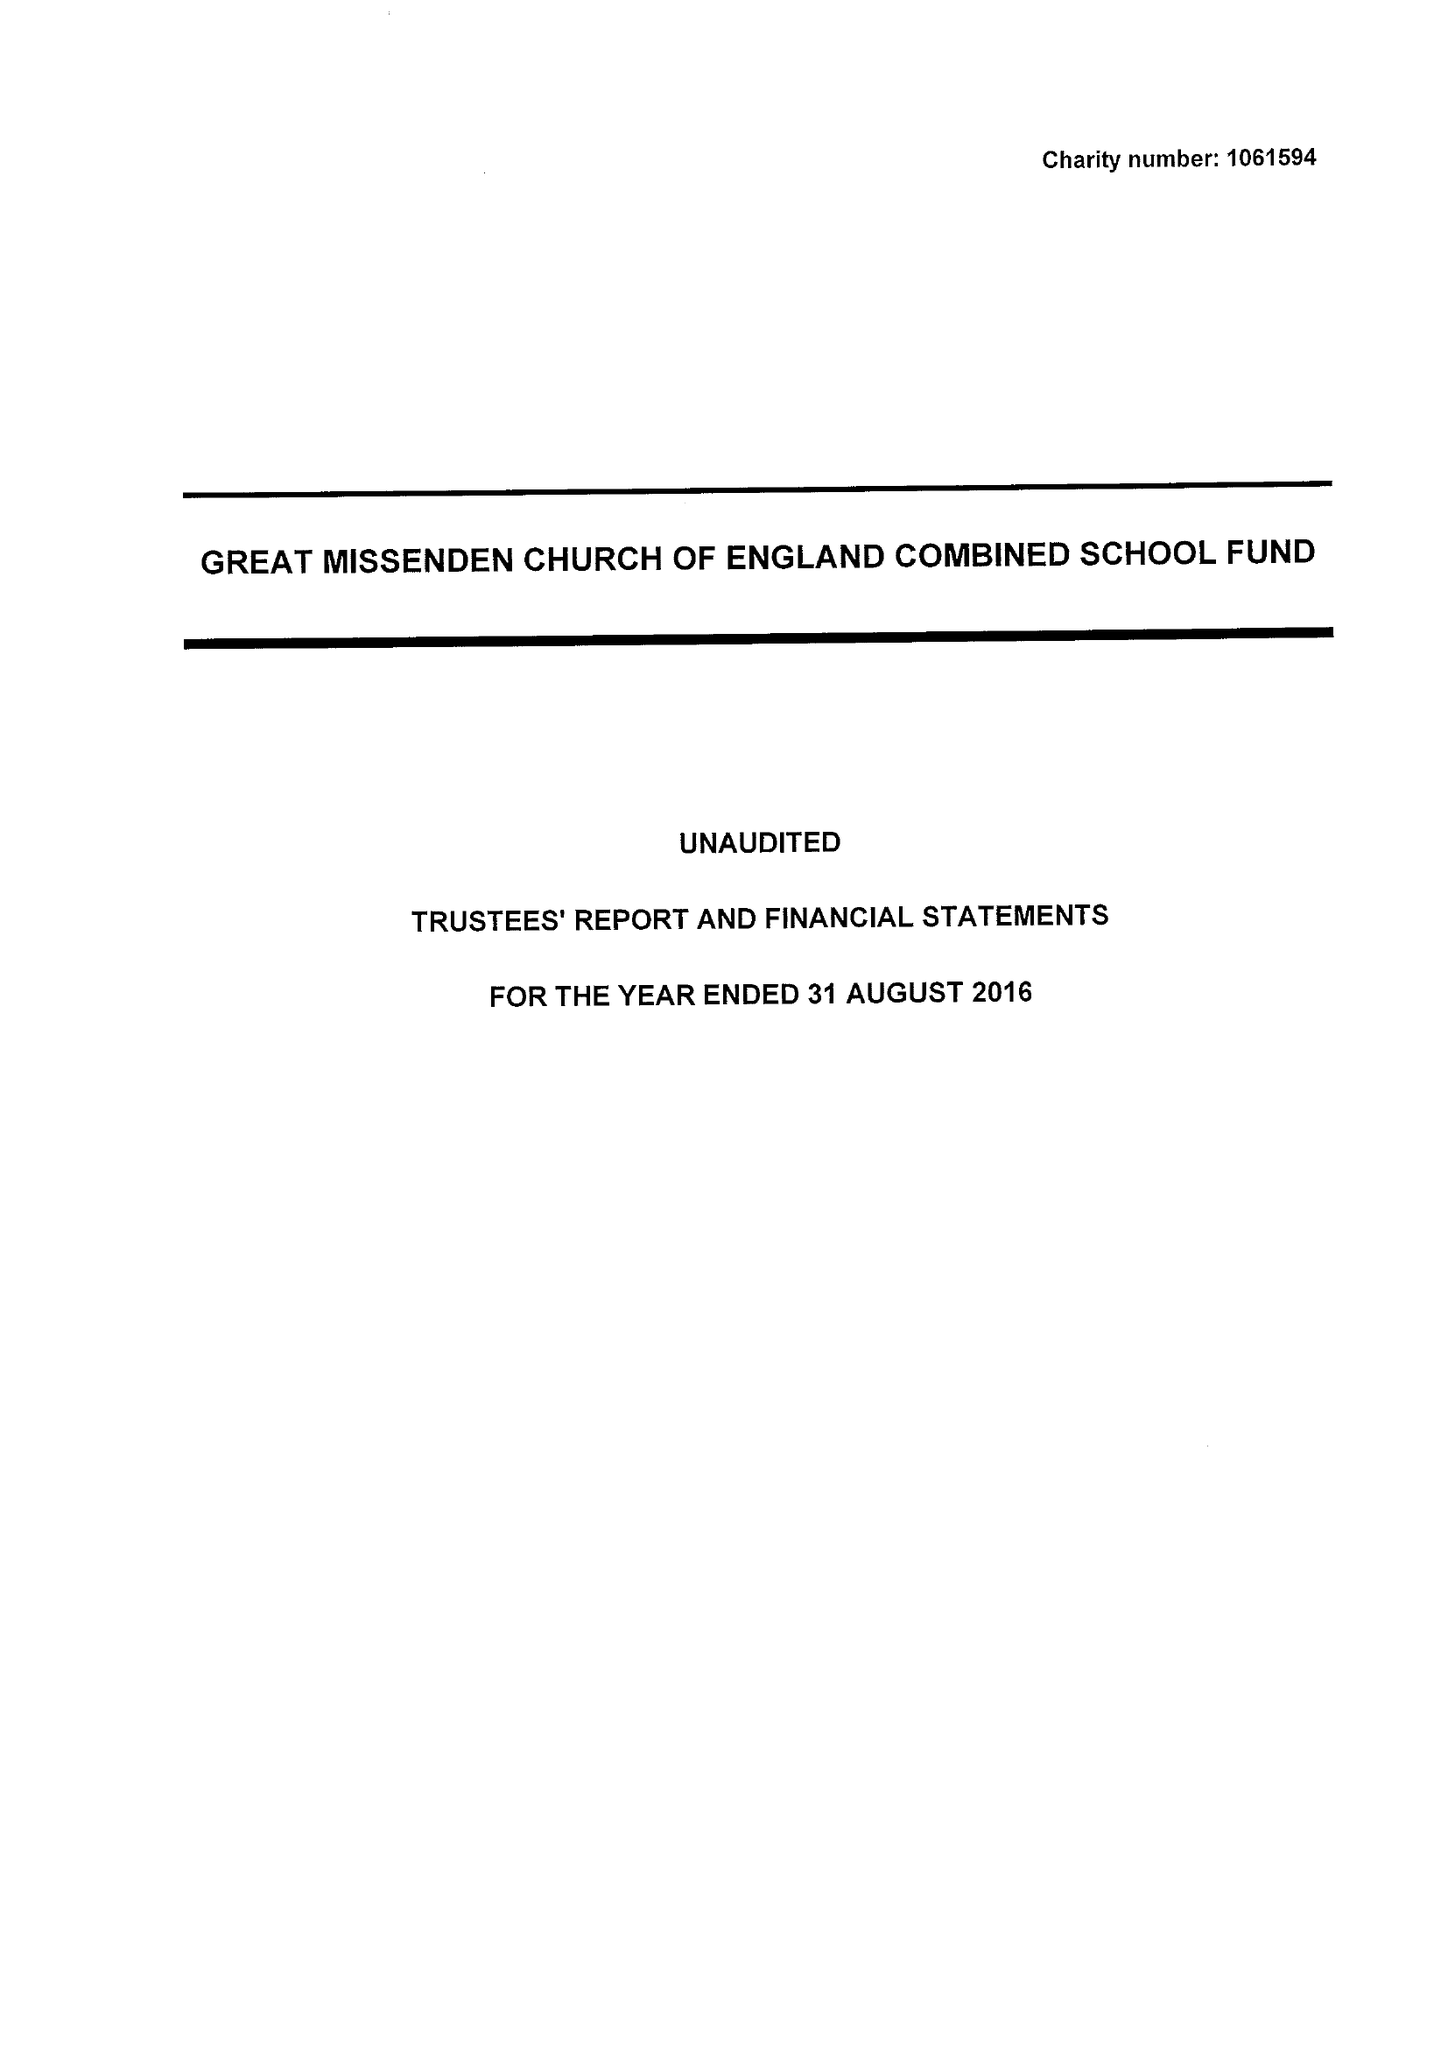What is the value for the income_annually_in_british_pounds?
Answer the question using a single word or phrase. 270680.00 